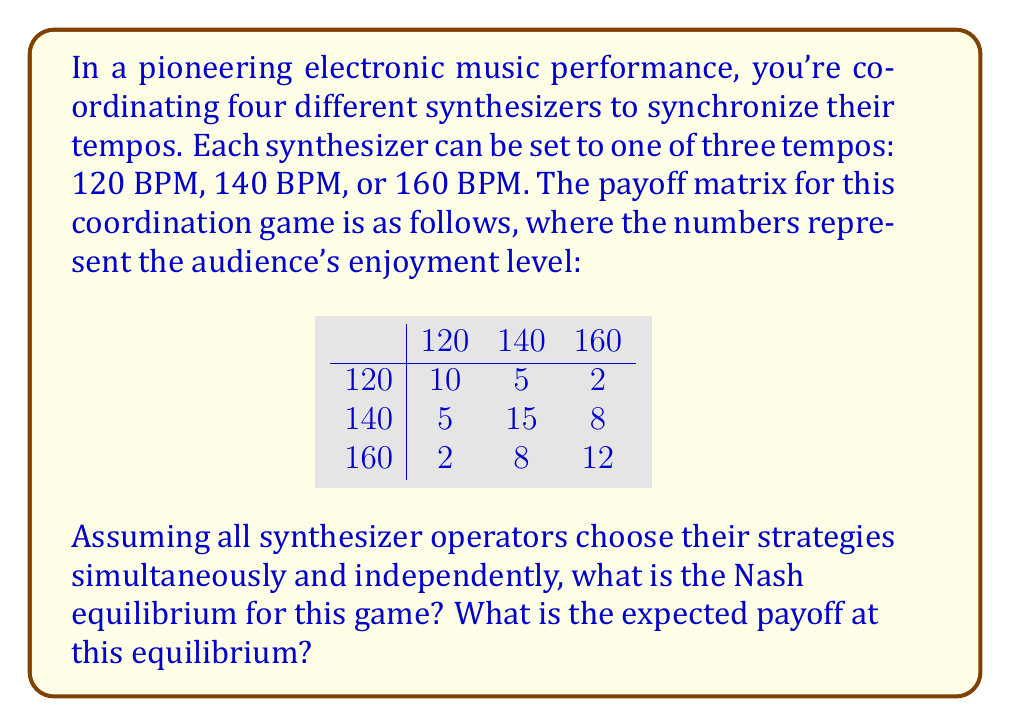Could you help me with this problem? To solve this coordination game, we need to identify the Nash equilibrium, which is a set of strategies where no player can unilaterally improve their payoff by changing their strategy.

Let's analyze each strategy:

1. If all players choose 120 BPM:
   - Payoff: 10
   - Deviation to 140 BPM or 160 BPM would lower payoff to 5 or 2

2. If all players choose 140 BPM:
   - Payoff: 15
   - Deviation to 120 BPM or 160 BPM would lower payoff to 5 or 8

3. If all players choose 160 BPM:
   - Payoff: 12
   - Deviation to 120 BPM or 140 BPM would lower payoff to 2 or 8

We can see that when all players choose 140 BPM, no individual player can improve their payoff by deviating. This makes (140, 140, 140, 140) the Nash equilibrium for this game.

To calculate the expected payoff at this equilibrium:

$$\text{Expected Payoff} = 15$$

This is because when all four synthesizers are set to 140 BPM, the audience's enjoyment level (payoff) is 15.
Answer: The Nash equilibrium is (140, 140, 140, 140), with an expected payoff of 15. 